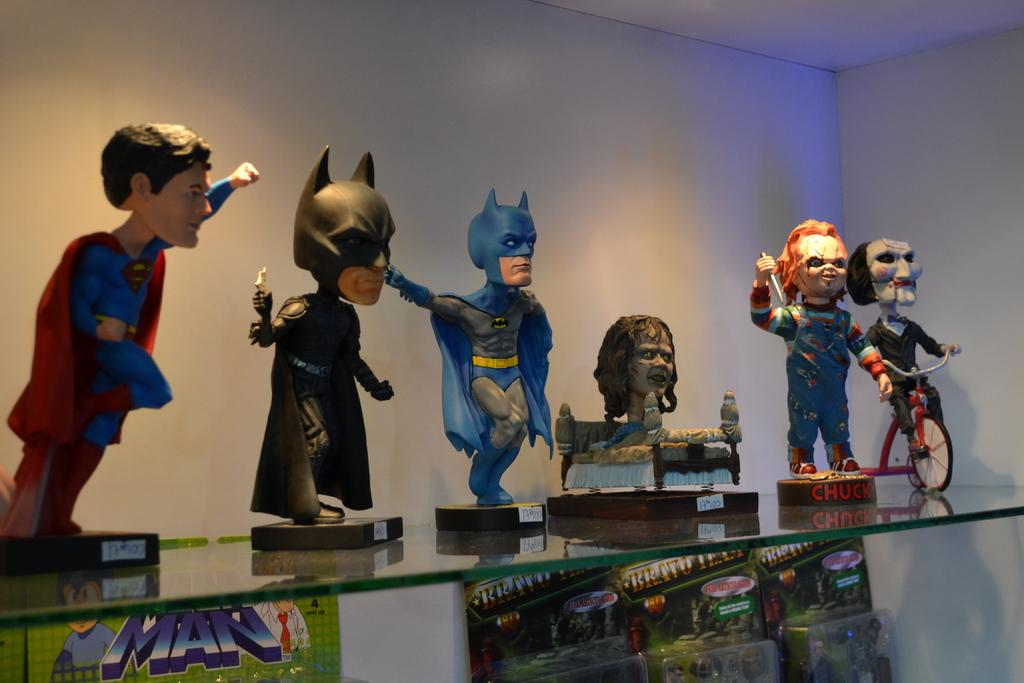What objects are on the glass shelf in the image? There are toys on a glass shelf in the image. What can be seen on the wall in the background of the image? There is a white color wall in the background of the image. How many toes are visible on the toys in the image? There are no visible toes on the toys in the image, as toys do not have toes. 